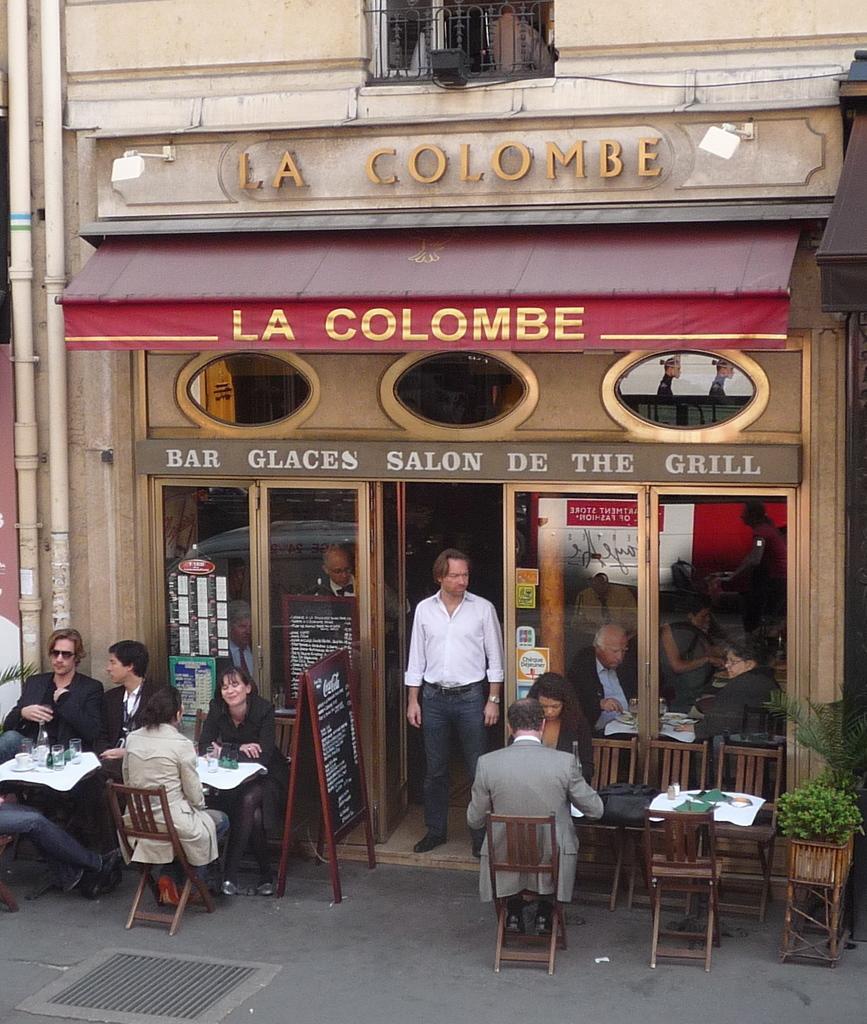Can you describe this image briefly? This is a picture taken in the outdoor, there are a group of people sitting on a chair in front of them there is a table on the table there is a glass and bottle. And a man is standing in front of the door. Background of this people is a hotel. 